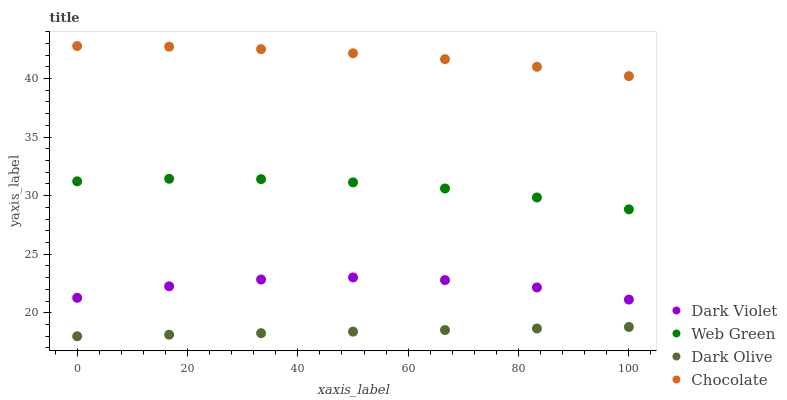Does Dark Olive have the minimum area under the curve?
Answer yes or no. Yes. Does Chocolate have the maximum area under the curve?
Answer yes or no. Yes. Does Web Green have the minimum area under the curve?
Answer yes or no. No. Does Web Green have the maximum area under the curve?
Answer yes or no. No. Is Dark Olive the smoothest?
Answer yes or no. Yes. Is Dark Violet the roughest?
Answer yes or no. Yes. Is Web Green the smoothest?
Answer yes or no. No. Is Web Green the roughest?
Answer yes or no. No. Does Dark Olive have the lowest value?
Answer yes or no. Yes. Does Web Green have the lowest value?
Answer yes or no. No. Does Chocolate have the highest value?
Answer yes or no. Yes. Does Web Green have the highest value?
Answer yes or no. No. Is Dark Violet less than Chocolate?
Answer yes or no. Yes. Is Chocolate greater than Web Green?
Answer yes or no. Yes. Does Dark Violet intersect Chocolate?
Answer yes or no. No. 